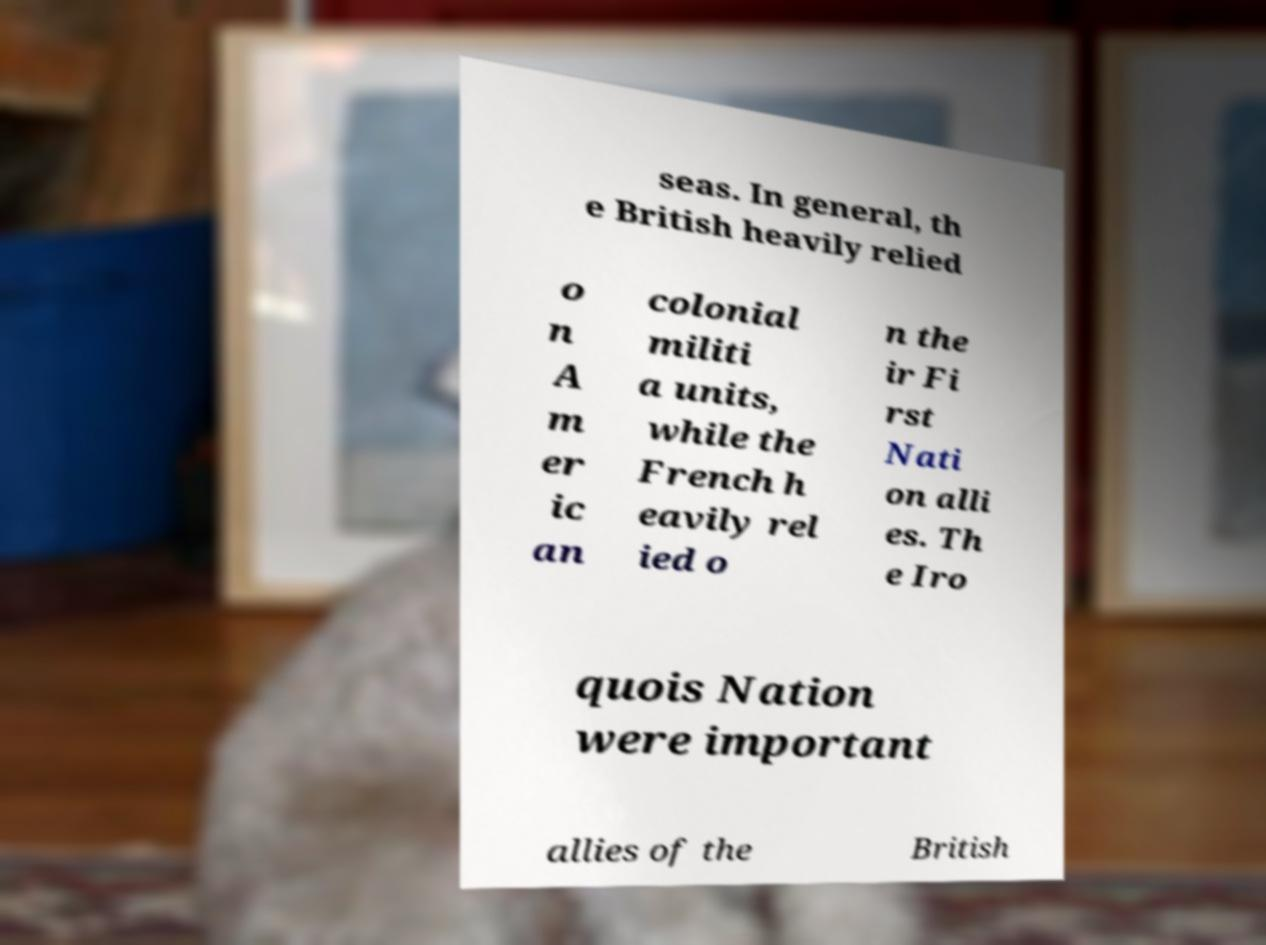Could you assist in decoding the text presented in this image and type it out clearly? seas. In general, th e British heavily relied o n A m er ic an colonial militi a units, while the French h eavily rel ied o n the ir Fi rst Nati on alli es. Th e Iro quois Nation were important allies of the British 